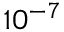<formula> <loc_0><loc_0><loc_500><loc_500>1 0 ^ { - 7 }</formula> 